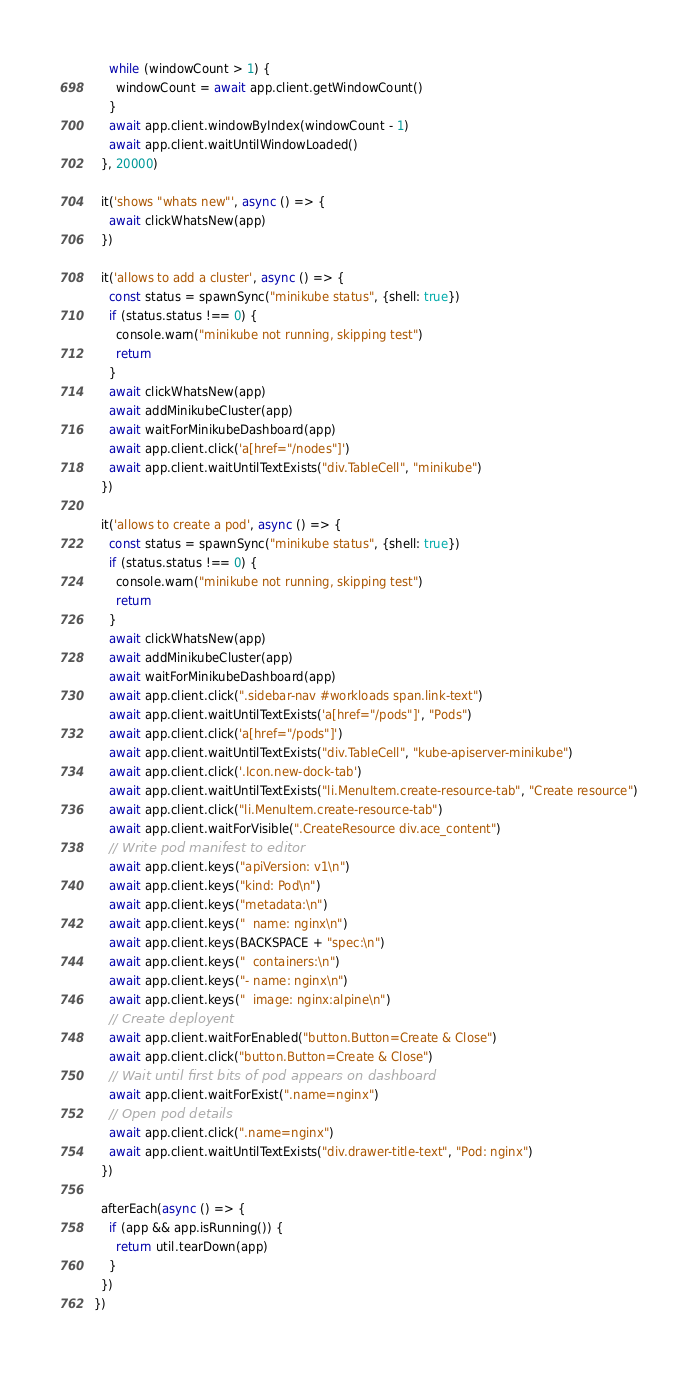<code> <loc_0><loc_0><loc_500><loc_500><_TypeScript_>    while (windowCount > 1) {
      windowCount = await app.client.getWindowCount()
    }
    await app.client.windowByIndex(windowCount - 1)
    await app.client.waitUntilWindowLoaded()
  }, 20000)

  it('shows "whats new"', async () => {
    await clickWhatsNew(app)
  })

  it('allows to add a cluster', async () => {
    const status = spawnSync("minikube status", {shell: true})
    if (status.status !== 0) {
      console.warn("minikube not running, skipping test")
      return
    }
    await clickWhatsNew(app)
    await addMinikubeCluster(app)
    await waitForMinikubeDashboard(app)
    await app.client.click('a[href="/nodes"]')
    await app.client.waitUntilTextExists("div.TableCell", "minikube")
  })

  it('allows to create a pod', async () => {
    const status = spawnSync("minikube status", {shell: true})
    if (status.status !== 0) {
      console.warn("minikube not running, skipping test")
      return
    }
    await clickWhatsNew(app)
    await addMinikubeCluster(app)
    await waitForMinikubeDashboard(app)
    await app.client.click(".sidebar-nav #workloads span.link-text")
    await app.client.waitUntilTextExists('a[href="/pods"]', "Pods")
    await app.client.click('a[href="/pods"]')
    await app.client.waitUntilTextExists("div.TableCell", "kube-apiserver-minikube")
    await app.client.click('.Icon.new-dock-tab')
    await app.client.waitUntilTextExists("li.MenuItem.create-resource-tab", "Create resource")
    await app.client.click("li.MenuItem.create-resource-tab")
    await app.client.waitForVisible(".CreateResource div.ace_content")
    // Write pod manifest to editor
    await app.client.keys("apiVersion: v1\n")
    await app.client.keys("kind: Pod\n")
    await app.client.keys("metadata:\n")
    await app.client.keys("  name: nginx\n")
    await app.client.keys(BACKSPACE + "spec:\n")
    await app.client.keys("  containers:\n")
    await app.client.keys("- name: nginx\n")
    await app.client.keys("  image: nginx:alpine\n")
    // Create deployent
    await app.client.waitForEnabled("button.Button=Create & Close")
    await app.client.click("button.Button=Create & Close")
    // Wait until first bits of pod appears on dashboard
    await app.client.waitForExist(".name=nginx")
    // Open pod details
    await app.client.click(".name=nginx")
    await app.client.waitUntilTextExists("div.drawer-title-text", "Pod: nginx")
  })

  afterEach(async () => {
    if (app && app.isRunning()) {
      return util.tearDown(app)
    }
  })
})
</code> 